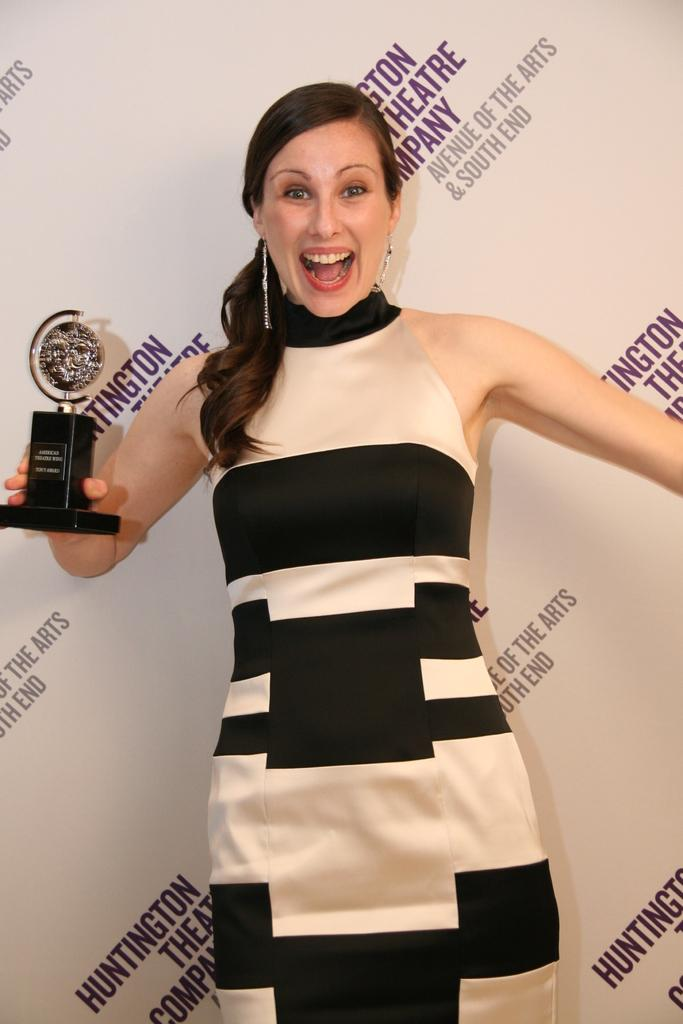<image>
Describe the image concisely. A woman holds an award in front of a wall that says Huntington Theatre Company. 